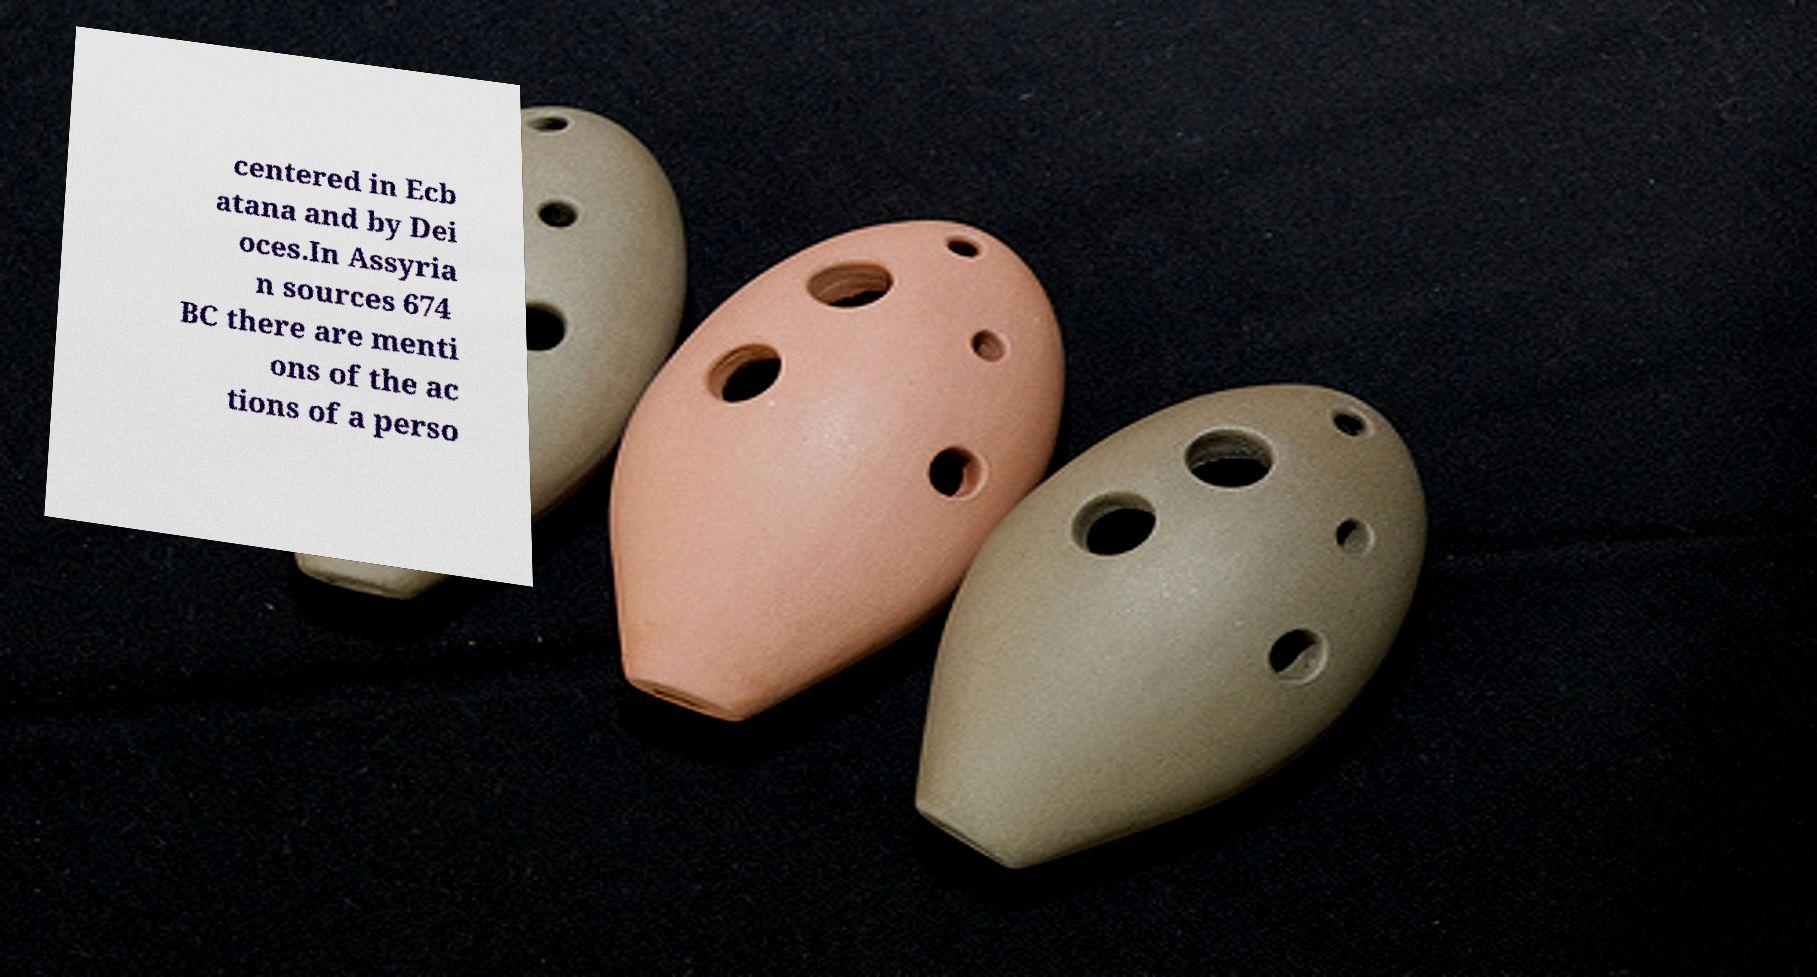There's text embedded in this image that I need extracted. Can you transcribe it verbatim? centered in Ecb atana and by Dei oces.In Assyria n sources 674 BC there are menti ons of the ac tions of a perso 